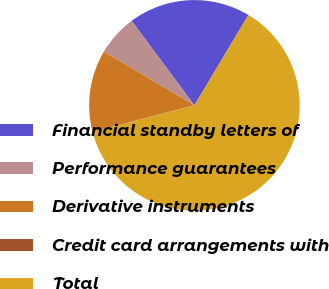Convert chart. <chart><loc_0><loc_0><loc_500><loc_500><pie_chart><fcel>Financial standby letters of<fcel>Performance guarantees<fcel>Derivative instruments<fcel>Credit card arrangements with<fcel>Total<nl><fcel>18.75%<fcel>6.3%<fcel>12.53%<fcel>0.08%<fcel>62.33%<nl></chart> 